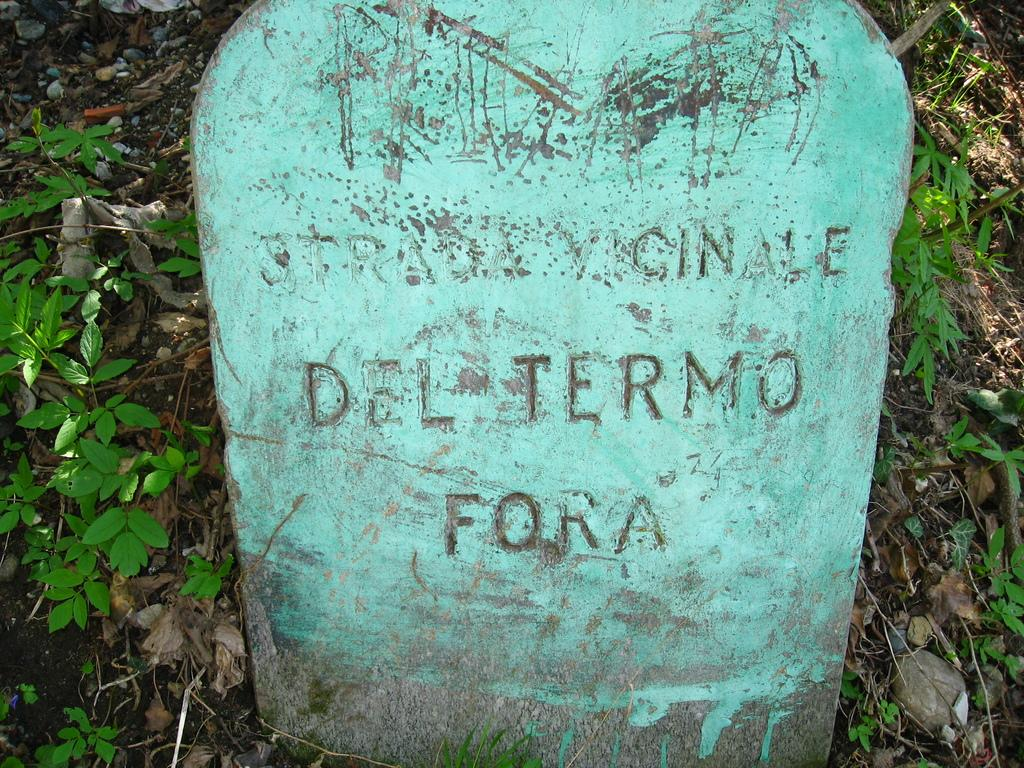What is the main object in the image? There is a stone in the image. Is there any text or writing on the stone? Yes, something is written on the stone. What else can be seen in the image besides the stone? There are plants in the image. What organization is responsible for maintaining the stone and plants in the image? There is no information about an organization responsible for maintaining the stone and plants in the image. 